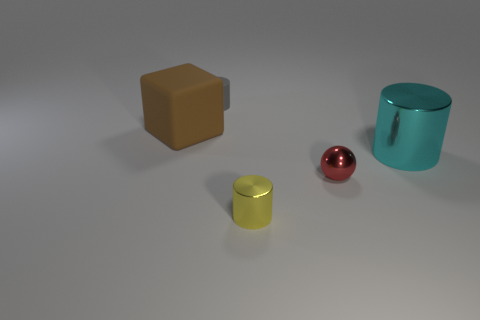Are there any metal objects of the same color as the large rubber block?
Keep it short and to the point. No. There is a metal cylinder that is behind the shiny cylinder that is to the left of the metal cylinder right of the yellow metallic cylinder; what is its color?
Make the answer very short. Cyan. Is the tiny gray object made of the same material as the tiny object that is to the right of the tiny yellow object?
Offer a terse response. No. What material is the brown object?
Offer a very short reply. Rubber. How many other things are there of the same material as the gray cylinder?
Ensure brevity in your answer.  1. There is a object that is right of the brown rubber block and behind the cyan metallic cylinder; what shape is it?
Keep it short and to the point. Cylinder. What color is the tiny cylinder that is made of the same material as the tiny sphere?
Keep it short and to the point. Yellow. Is the number of shiny things that are in front of the tiny red shiny ball the same as the number of tiny cyan shiny spheres?
Your response must be concise. No. There is a red object that is the same size as the matte cylinder; what is its shape?
Ensure brevity in your answer.  Sphere. How many other objects are there of the same shape as the big brown object?
Offer a very short reply. 0. 